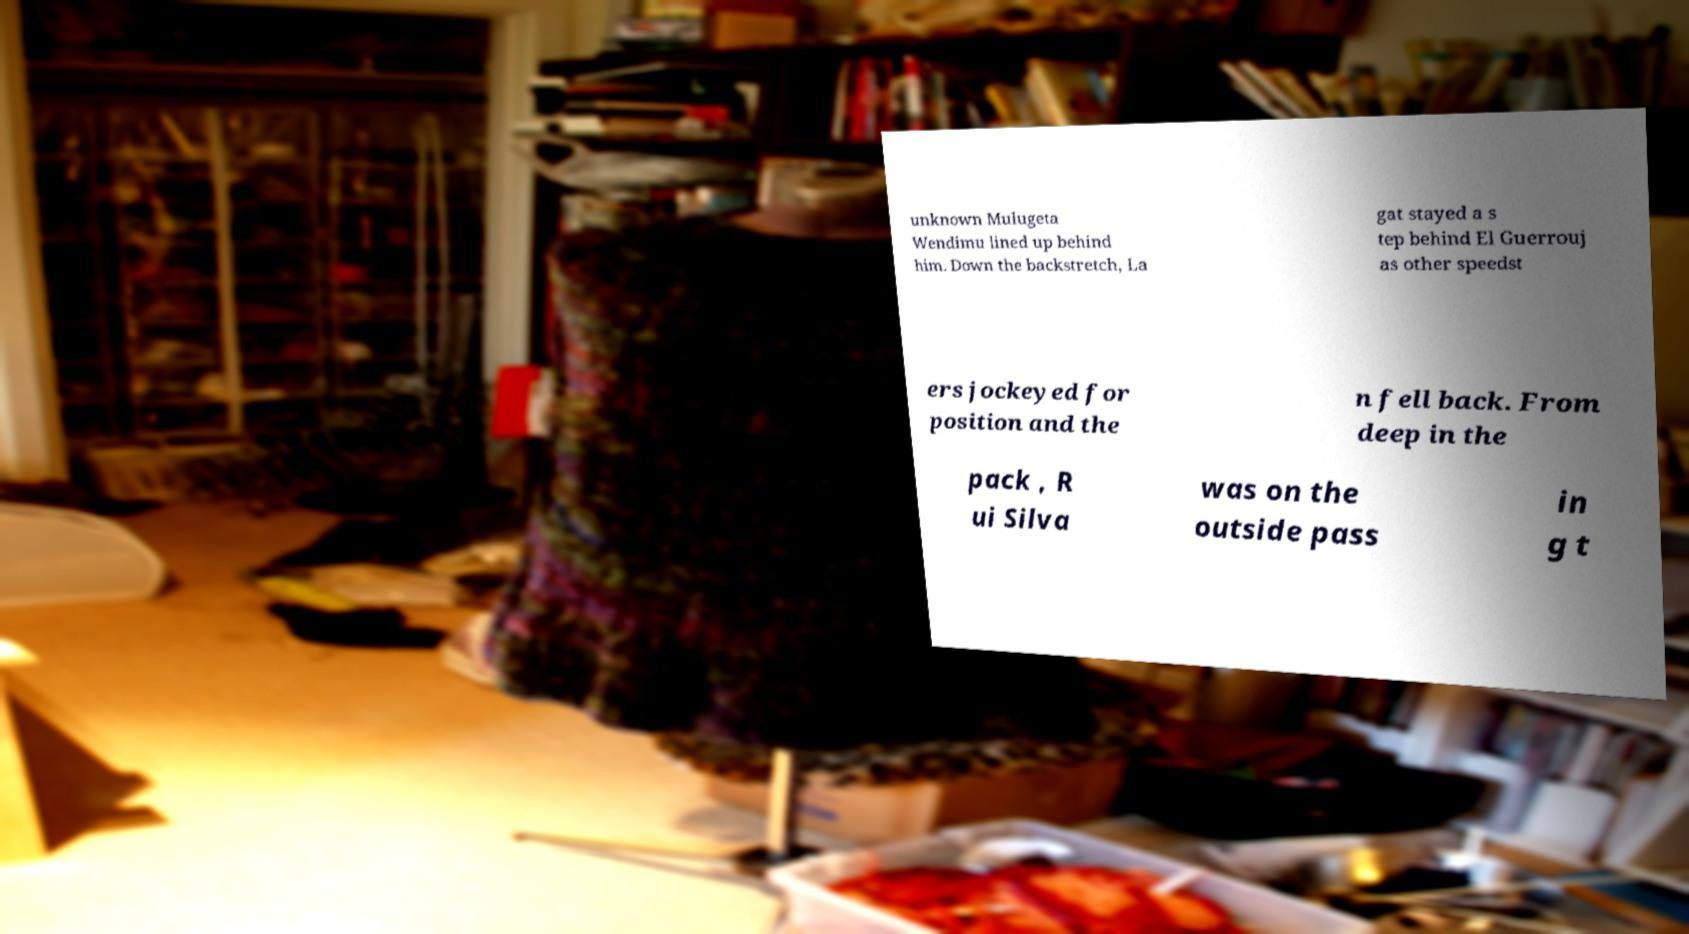For documentation purposes, I need the text within this image transcribed. Could you provide that? unknown Mulugeta Wendimu lined up behind him. Down the backstretch, La gat stayed a s tep behind El Guerrouj as other speedst ers jockeyed for position and the n fell back. From deep in the pack , R ui Silva was on the outside pass in g t 